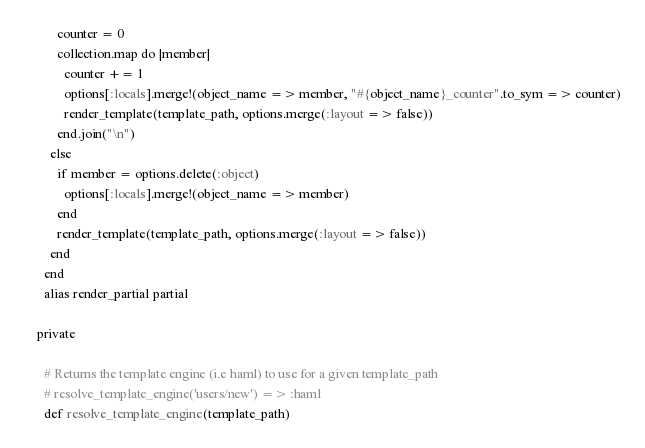Convert code to text. <code><loc_0><loc_0><loc_500><loc_500><_Ruby_>          counter = 0
          collection.map do |member|
            counter += 1
            options[:locals].merge!(object_name => member, "#{object_name}_counter".to_sym => counter)
            render_template(template_path, options.merge(:layout => false))
          end.join("\n")
        else
          if member = options.delete(:object)
            options[:locals].merge!(object_name => member)
          end
          render_template(template_path, options.merge(:layout => false))
        end
      end
      alias render_partial partial

    private

      # Returns the template engine (i.e haml) to use for a given template_path
      # resolve_template_engine('users/new') => :haml
      def resolve_template_engine(template_path)</code> 